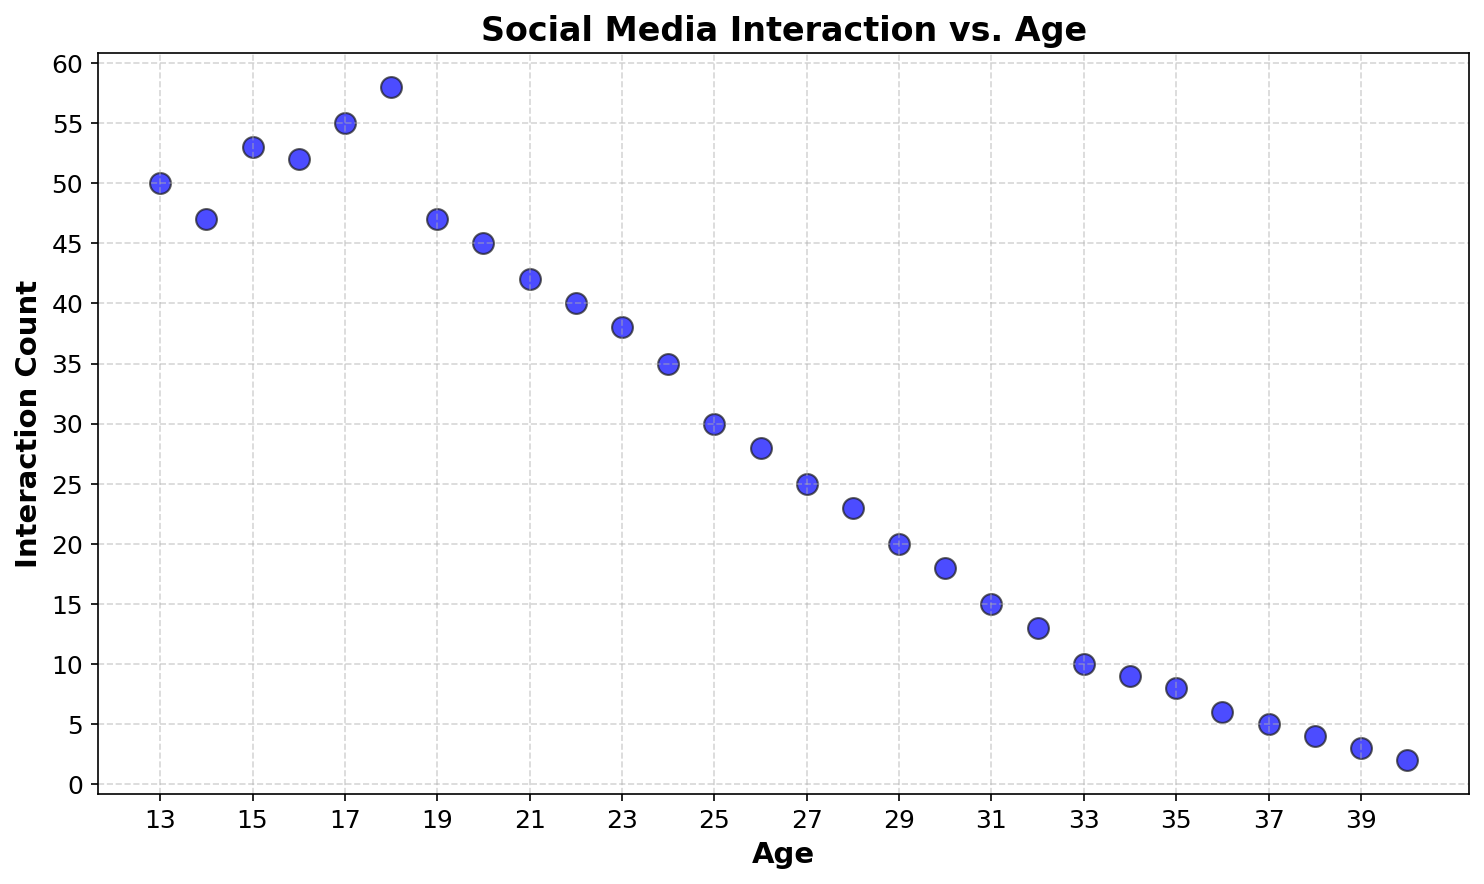What's the age range of people with the highest social media interaction count? The highest social media interaction count is 58. By observing the scatter plot, we see that this peak interaction happens at age 18. So, the age range is 18.
Answer: 18 Which age group shows the most significant decline in social media interactions? By examining the scatter plot, we can observe that there is a sharp decline in interaction count between ages 18 and 20. The interaction count drops from 58 at age 18 to 45 at age 20, which is a significant decline.
Answer: Age 18 to 20 What is the average social media interaction count for ages between 20 and 30? First, locate the interaction counts for ages 20 to 30: 45, 42, 40, 38, 35, 30, 28, 25, 23, and 20. Sum these values (45 + 42 + 40 + 38 + 35 + 30 + 28 + 25 + 23 + 20) which equals 326. Divide by the number of ages (10) to get the average: 326/10 = 32.6.
Answer: 32.6 From which age does the social media interaction count consistently drop below 10? Check the points in the scatter plot to find where the social media interaction count is consistently below 10. This occurs starting at age 34 and continues to age 40.
Answer: 34 What is the difference in social media interactions between ages 13 and 25? Look at the scatter plot for the interaction counts at age 13 (50) and age 25 (30). Subtract to find the difference: 50 - 30 = 20.
Answer: 20 Which age has the lowest social media interaction count, and what is that count? Locate the point with the lowest interaction count on the scatter plot. Ages 39 and 40 both have the lowest interaction count of 2 and 3, respectively.
Answer: Age 40 with a count of 2 What is the range of social media interaction counts from ages 15 to 25? Look at the interaction counts within ages 15 to 25: 53, 52, 55, 58, 47, 45, 42, 40, 38, 35, 30. The highest value is 58 (at age 18), and the lowest is 30 (at age 25). The range is 58 - 30 = 28.
Answer: 28 At what ages is the social media interaction count approximately 20? Locate points where the interaction count is around 20. The scatter plot shows interaction counts of 20 at ages 29.
Answer: 29 How does the social media interaction count at age 14 compare to that at age 32? Check the values at ages 14 (47) and 32 (13) on the scatter plot. Compare the counts: 47 at age 14 is significantly higher than 13 at age 32.
Answer: Age 14 has significantly more interactions 